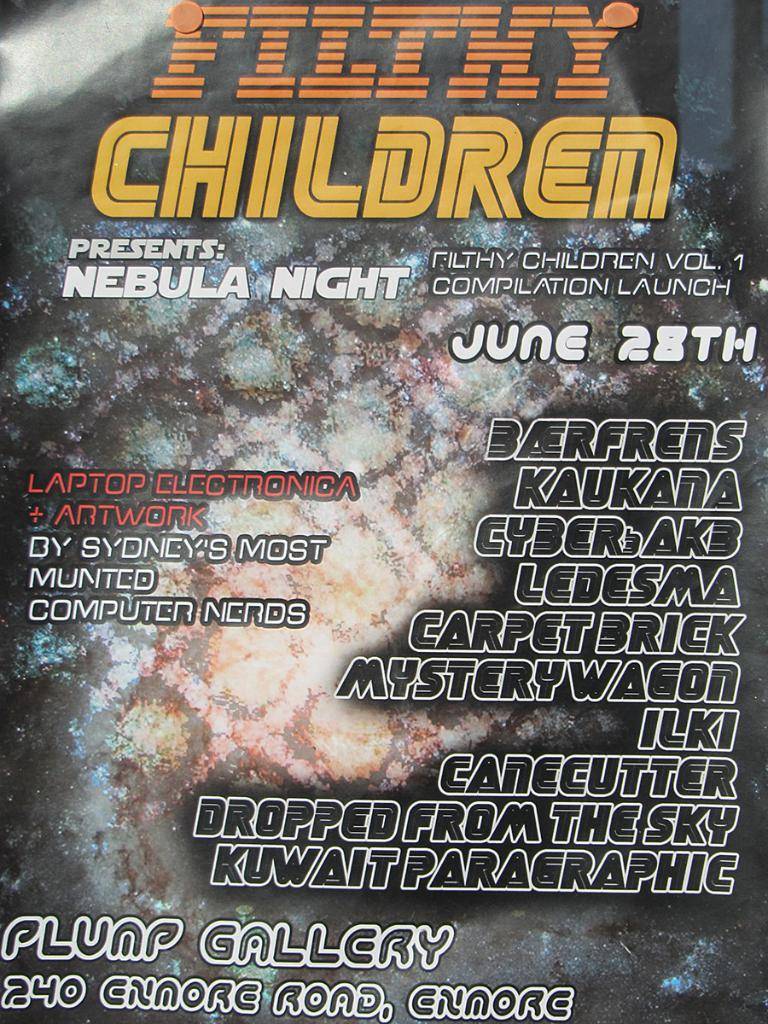What can be seen on the floor in the image? There is a design on the floor in the image. Are there any words or phrases written in the image? Yes, there are texts written on the image. What song is being sung by the stranger in the image? There is no stranger or song present in the image. How many bananas are visible in the image? There are no bananas present in the image. 